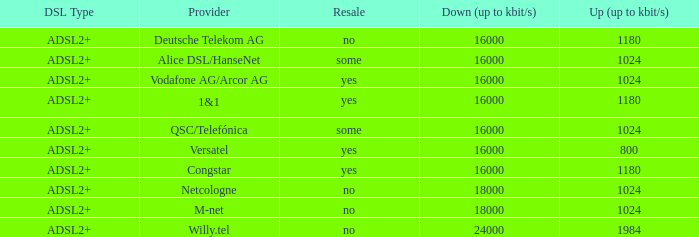What are all the dsl type offered by the M-Net telecom company? ADSL2+. 